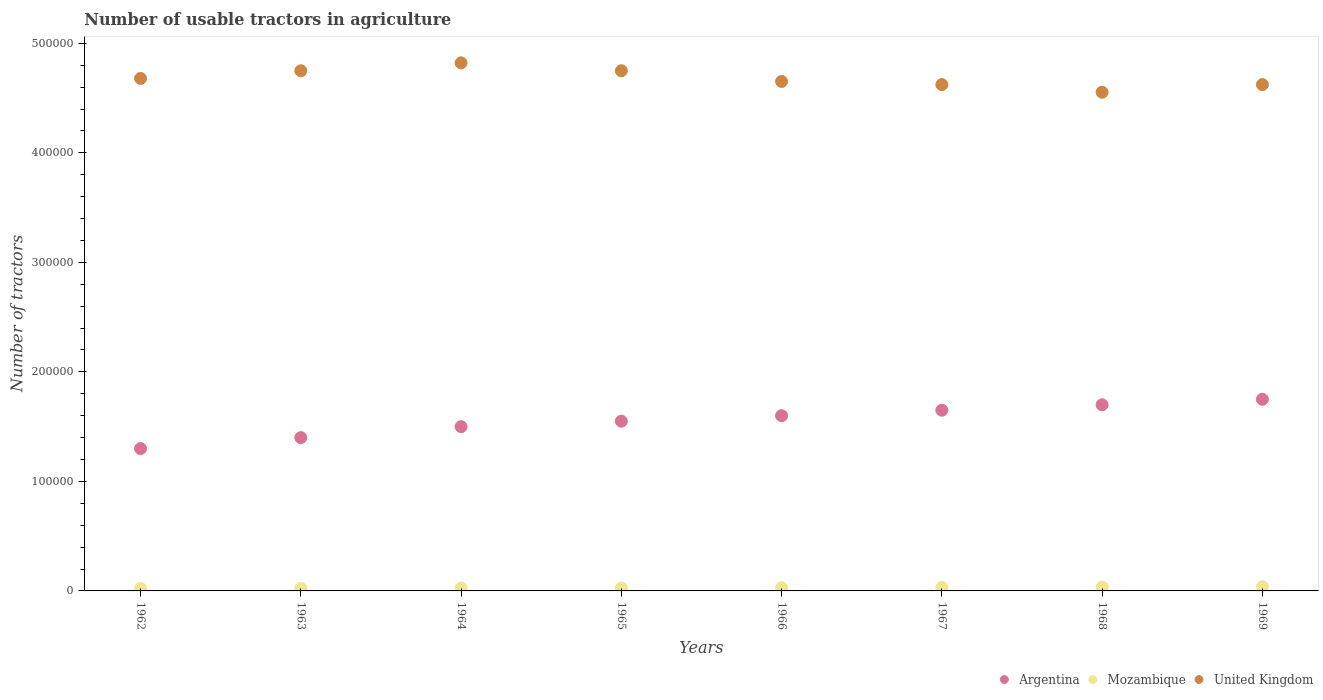What is the number of usable tractors in agriculture in Mozambique in 1966?
Give a very brief answer. 2948. Across all years, what is the maximum number of usable tractors in agriculture in Mozambique?
Provide a short and direct response. 3900. Across all years, what is the minimum number of usable tractors in agriculture in Mozambique?
Your answer should be compact. 2300. In which year was the number of usable tractors in agriculture in Mozambique maximum?
Give a very brief answer. 1969. In which year was the number of usable tractors in agriculture in United Kingdom minimum?
Make the answer very short. 1968. What is the total number of usable tractors in agriculture in Mozambique in the graph?
Your answer should be very brief. 2.38e+04. What is the difference between the number of usable tractors in agriculture in Mozambique in 1963 and that in 1964?
Make the answer very short. -150. What is the difference between the number of usable tractors in agriculture in Argentina in 1966 and the number of usable tractors in agriculture in United Kingdom in 1964?
Provide a succinct answer. -3.22e+05. What is the average number of usable tractors in agriculture in Mozambique per year?
Give a very brief answer. 2981. In the year 1969, what is the difference between the number of usable tractors in agriculture in Argentina and number of usable tractors in agriculture in United Kingdom?
Ensure brevity in your answer.  -2.87e+05. In how many years, is the number of usable tractors in agriculture in United Kingdom greater than 280000?
Make the answer very short. 8. What is the ratio of the number of usable tractors in agriculture in Argentina in 1966 to that in 1967?
Keep it short and to the point. 0.97. Is the number of usable tractors in agriculture in United Kingdom in 1965 less than that in 1968?
Give a very brief answer. No. Is the difference between the number of usable tractors in agriculture in Argentina in 1967 and 1969 greater than the difference between the number of usable tractors in agriculture in United Kingdom in 1967 and 1969?
Ensure brevity in your answer.  No. What is the difference between the highest and the second highest number of usable tractors in agriculture in United Kingdom?
Keep it short and to the point. 7210. What is the difference between the highest and the lowest number of usable tractors in agriculture in United Kingdom?
Provide a succinct answer. 2.68e+04. Is it the case that in every year, the sum of the number of usable tractors in agriculture in Argentina and number of usable tractors in agriculture in Mozambique  is greater than the number of usable tractors in agriculture in United Kingdom?
Your answer should be compact. No. Does the number of usable tractors in agriculture in Mozambique monotonically increase over the years?
Your answer should be very brief. Yes. How many dotlines are there?
Provide a succinct answer. 3. Does the graph contain any zero values?
Provide a short and direct response. No. Does the graph contain grids?
Provide a short and direct response. No. Where does the legend appear in the graph?
Provide a short and direct response. Bottom right. What is the title of the graph?
Give a very brief answer. Number of usable tractors in agriculture. What is the label or title of the X-axis?
Ensure brevity in your answer.  Years. What is the label or title of the Y-axis?
Make the answer very short. Number of tractors. What is the Number of tractors in Argentina in 1962?
Keep it short and to the point. 1.30e+05. What is the Number of tractors in Mozambique in 1962?
Keep it short and to the point. 2300. What is the Number of tractors in United Kingdom in 1962?
Your answer should be compact. 4.68e+05. What is the Number of tractors of Argentina in 1963?
Offer a terse response. 1.40e+05. What is the Number of tractors in Mozambique in 1963?
Your answer should be very brief. 2450. What is the Number of tractors in United Kingdom in 1963?
Give a very brief answer. 4.75e+05. What is the Number of tractors in Mozambique in 1964?
Offer a terse response. 2600. What is the Number of tractors in United Kingdom in 1964?
Keep it short and to the point. 4.82e+05. What is the Number of tractors of Argentina in 1965?
Make the answer very short. 1.55e+05. What is the Number of tractors in Mozambique in 1965?
Your answer should be compact. 2750. What is the Number of tractors of United Kingdom in 1965?
Keep it short and to the point. 4.75e+05. What is the Number of tractors of Mozambique in 1966?
Offer a very short reply. 2948. What is the Number of tractors of United Kingdom in 1966?
Provide a short and direct response. 4.65e+05. What is the Number of tractors in Argentina in 1967?
Keep it short and to the point. 1.65e+05. What is the Number of tractors in Mozambique in 1967?
Your answer should be compact. 3300. What is the Number of tractors of United Kingdom in 1967?
Your response must be concise. 4.62e+05. What is the Number of tractors of Mozambique in 1968?
Ensure brevity in your answer.  3600. What is the Number of tractors of United Kingdom in 1968?
Provide a succinct answer. 4.55e+05. What is the Number of tractors in Argentina in 1969?
Offer a terse response. 1.75e+05. What is the Number of tractors of Mozambique in 1969?
Ensure brevity in your answer.  3900. What is the Number of tractors of United Kingdom in 1969?
Your answer should be very brief. 4.62e+05. Across all years, what is the maximum Number of tractors in Argentina?
Provide a short and direct response. 1.75e+05. Across all years, what is the maximum Number of tractors of Mozambique?
Offer a terse response. 3900. Across all years, what is the maximum Number of tractors in United Kingdom?
Your response must be concise. 4.82e+05. Across all years, what is the minimum Number of tractors of Argentina?
Provide a short and direct response. 1.30e+05. Across all years, what is the minimum Number of tractors in Mozambique?
Your response must be concise. 2300. Across all years, what is the minimum Number of tractors in United Kingdom?
Ensure brevity in your answer.  4.55e+05. What is the total Number of tractors of Argentina in the graph?
Offer a terse response. 1.24e+06. What is the total Number of tractors of Mozambique in the graph?
Give a very brief answer. 2.38e+04. What is the total Number of tractors in United Kingdom in the graph?
Ensure brevity in your answer.  3.75e+06. What is the difference between the Number of tractors in Mozambique in 1962 and that in 1963?
Your answer should be compact. -150. What is the difference between the Number of tractors in United Kingdom in 1962 and that in 1963?
Ensure brevity in your answer.  -7000. What is the difference between the Number of tractors of Mozambique in 1962 and that in 1964?
Provide a short and direct response. -300. What is the difference between the Number of tractors of United Kingdom in 1962 and that in 1964?
Provide a short and direct response. -1.42e+04. What is the difference between the Number of tractors in Argentina in 1962 and that in 1965?
Provide a short and direct response. -2.50e+04. What is the difference between the Number of tractors of Mozambique in 1962 and that in 1965?
Your answer should be compact. -450. What is the difference between the Number of tractors in United Kingdom in 1962 and that in 1965?
Ensure brevity in your answer.  -7000. What is the difference between the Number of tractors in Mozambique in 1962 and that in 1966?
Your response must be concise. -648. What is the difference between the Number of tractors in United Kingdom in 1962 and that in 1966?
Your answer should be compact. 2780. What is the difference between the Number of tractors in Argentina in 1962 and that in 1967?
Give a very brief answer. -3.50e+04. What is the difference between the Number of tractors in Mozambique in 1962 and that in 1967?
Make the answer very short. -1000. What is the difference between the Number of tractors in United Kingdom in 1962 and that in 1967?
Give a very brief answer. 5637. What is the difference between the Number of tractors in Argentina in 1962 and that in 1968?
Ensure brevity in your answer.  -4.00e+04. What is the difference between the Number of tractors in Mozambique in 1962 and that in 1968?
Ensure brevity in your answer.  -1300. What is the difference between the Number of tractors of United Kingdom in 1962 and that in 1968?
Make the answer very short. 1.26e+04. What is the difference between the Number of tractors of Argentina in 1962 and that in 1969?
Provide a short and direct response. -4.50e+04. What is the difference between the Number of tractors in Mozambique in 1962 and that in 1969?
Your answer should be compact. -1600. What is the difference between the Number of tractors of United Kingdom in 1962 and that in 1969?
Make the answer very short. 5624. What is the difference between the Number of tractors of Mozambique in 1963 and that in 1964?
Your response must be concise. -150. What is the difference between the Number of tractors of United Kingdom in 1963 and that in 1964?
Make the answer very short. -7210. What is the difference between the Number of tractors in Argentina in 1963 and that in 1965?
Provide a succinct answer. -1.50e+04. What is the difference between the Number of tractors of Mozambique in 1963 and that in 1965?
Give a very brief answer. -300. What is the difference between the Number of tractors in Mozambique in 1963 and that in 1966?
Give a very brief answer. -498. What is the difference between the Number of tractors in United Kingdom in 1963 and that in 1966?
Provide a succinct answer. 9780. What is the difference between the Number of tractors in Argentina in 1963 and that in 1967?
Your response must be concise. -2.50e+04. What is the difference between the Number of tractors of Mozambique in 1963 and that in 1967?
Your answer should be compact. -850. What is the difference between the Number of tractors of United Kingdom in 1963 and that in 1967?
Your answer should be very brief. 1.26e+04. What is the difference between the Number of tractors in Mozambique in 1963 and that in 1968?
Keep it short and to the point. -1150. What is the difference between the Number of tractors of United Kingdom in 1963 and that in 1968?
Keep it short and to the point. 1.96e+04. What is the difference between the Number of tractors in Argentina in 1963 and that in 1969?
Offer a very short reply. -3.50e+04. What is the difference between the Number of tractors in Mozambique in 1963 and that in 1969?
Your response must be concise. -1450. What is the difference between the Number of tractors in United Kingdom in 1963 and that in 1969?
Your answer should be very brief. 1.26e+04. What is the difference between the Number of tractors of Argentina in 1964 and that in 1965?
Your response must be concise. -5000. What is the difference between the Number of tractors of Mozambique in 1964 and that in 1965?
Make the answer very short. -150. What is the difference between the Number of tractors of United Kingdom in 1964 and that in 1965?
Provide a succinct answer. 7210. What is the difference between the Number of tractors in Mozambique in 1964 and that in 1966?
Provide a succinct answer. -348. What is the difference between the Number of tractors in United Kingdom in 1964 and that in 1966?
Provide a short and direct response. 1.70e+04. What is the difference between the Number of tractors in Argentina in 1964 and that in 1967?
Offer a very short reply. -1.50e+04. What is the difference between the Number of tractors in Mozambique in 1964 and that in 1967?
Give a very brief answer. -700. What is the difference between the Number of tractors of United Kingdom in 1964 and that in 1967?
Provide a short and direct response. 1.98e+04. What is the difference between the Number of tractors in Mozambique in 1964 and that in 1968?
Offer a very short reply. -1000. What is the difference between the Number of tractors of United Kingdom in 1964 and that in 1968?
Your answer should be very brief. 2.68e+04. What is the difference between the Number of tractors in Argentina in 1964 and that in 1969?
Your answer should be compact. -2.50e+04. What is the difference between the Number of tractors in Mozambique in 1964 and that in 1969?
Offer a very short reply. -1300. What is the difference between the Number of tractors in United Kingdom in 1964 and that in 1969?
Your answer should be very brief. 1.98e+04. What is the difference between the Number of tractors of Argentina in 1965 and that in 1966?
Provide a short and direct response. -5000. What is the difference between the Number of tractors in Mozambique in 1965 and that in 1966?
Make the answer very short. -198. What is the difference between the Number of tractors of United Kingdom in 1965 and that in 1966?
Offer a terse response. 9780. What is the difference between the Number of tractors in Mozambique in 1965 and that in 1967?
Your answer should be compact. -550. What is the difference between the Number of tractors of United Kingdom in 1965 and that in 1967?
Provide a short and direct response. 1.26e+04. What is the difference between the Number of tractors of Argentina in 1965 and that in 1968?
Provide a short and direct response. -1.50e+04. What is the difference between the Number of tractors of Mozambique in 1965 and that in 1968?
Give a very brief answer. -850. What is the difference between the Number of tractors in United Kingdom in 1965 and that in 1968?
Your response must be concise. 1.96e+04. What is the difference between the Number of tractors of Argentina in 1965 and that in 1969?
Offer a very short reply. -2.00e+04. What is the difference between the Number of tractors of Mozambique in 1965 and that in 1969?
Keep it short and to the point. -1150. What is the difference between the Number of tractors in United Kingdom in 1965 and that in 1969?
Give a very brief answer. 1.26e+04. What is the difference between the Number of tractors in Argentina in 1966 and that in 1967?
Provide a short and direct response. -5000. What is the difference between the Number of tractors of Mozambique in 1966 and that in 1967?
Your response must be concise. -352. What is the difference between the Number of tractors in United Kingdom in 1966 and that in 1967?
Keep it short and to the point. 2857. What is the difference between the Number of tractors in Argentina in 1966 and that in 1968?
Your answer should be compact. -10000. What is the difference between the Number of tractors in Mozambique in 1966 and that in 1968?
Keep it short and to the point. -652. What is the difference between the Number of tractors in United Kingdom in 1966 and that in 1968?
Give a very brief answer. 9845. What is the difference between the Number of tractors of Argentina in 1966 and that in 1969?
Provide a short and direct response. -1.50e+04. What is the difference between the Number of tractors in Mozambique in 1966 and that in 1969?
Give a very brief answer. -952. What is the difference between the Number of tractors in United Kingdom in 1966 and that in 1969?
Your answer should be compact. 2844. What is the difference between the Number of tractors in Argentina in 1967 and that in 1968?
Keep it short and to the point. -5000. What is the difference between the Number of tractors of Mozambique in 1967 and that in 1968?
Your answer should be very brief. -300. What is the difference between the Number of tractors of United Kingdom in 1967 and that in 1968?
Provide a short and direct response. 6988. What is the difference between the Number of tractors in Mozambique in 1967 and that in 1969?
Keep it short and to the point. -600. What is the difference between the Number of tractors in United Kingdom in 1967 and that in 1969?
Provide a short and direct response. -13. What is the difference between the Number of tractors in Argentina in 1968 and that in 1969?
Your response must be concise. -5000. What is the difference between the Number of tractors of Mozambique in 1968 and that in 1969?
Your response must be concise. -300. What is the difference between the Number of tractors of United Kingdom in 1968 and that in 1969?
Give a very brief answer. -7001. What is the difference between the Number of tractors in Argentina in 1962 and the Number of tractors in Mozambique in 1963?
Your response must be concise. 1.28e+05. What is the difference between the Number of tractors of Argentina in 1962 and the Number of tractors of United Kingdom in 1963?
Ensure brevity in your answer.  -3.45e+05. What is the difference between the Number of tractors in Mozambique in 1962 and the Number of tractors in United Kingdom in 1963?
Keep it short and to the point. -4.73e+05. What is the difference between the Number of tractors in Argentina in 1962 and the Number of tractors in Mozambique in 1964?
Your answer should be very brief. 1.27e+05. What is the difference between the Number of tractors of Argentina in 1962 and the Number of tractors of United Kingdom in 1964?
Offer a very short reply. -3.52e+05. What is the difference between the Number of tractors in Mozambique in 1962 and the Number of tractors in United Kingdom in 1964?
Your response must be concise. -4.80e+05. What is the difference between the Number of tractors in Argentina in 1962 and the Number of tractors in Mozambique in 1965?
Give a very brief answer. 1.27e+05. What is the difference between the Number of tractors of Argentina in 1962 and the Number of tractors of United Kingdom in 1965?
Give a very brief answer. -3.45e+05. What is the difference between the Number of tractors in Mozambique in 1962 and the Number of tractors in United Kingdom in 1965?
Provide a short and direct response. -4.73e+05. What is the difference between the Number of tractors in Argentina in 1962 and the Number of tractors in Mozambique in 1966?
Offer a terse response. 1.27e+05. What is the difference between the Number of tractors of Argentina in 1962 and the Number of tractors of United Kingdom in 1966?
Your response must be concise. -3.35e+05. What is the difference between the Number of tractors of Mozambique in 1962 and the Number of tractors of United Kingdom in 1966?
Offer a terse response. -4.63e+05. What is the difference between the Number of tractors of Argentina in 1962 and the Number of tractors of Mozambique in 1967?
Make the answer very short. 1.27e+05. What is the difference between the Number of tractors in Argentina in 1962 and the Number of tractors in United Kingdom in 1967?
Offer a terse response. -3.32e+05. What is the difference between the Number of tractors of Mozambique in 1962 and the Number of tractors of United Kingdom in 1967?
Keep it short and to the point. -4.60e+05. What is the difference between the Number of tractors in Argentina in 1962 and the Number of tractors in Mozambique in 1968?
Offer a terse response. 1.26e+05. What is the difference between the Number of tractors in Argentina in 1962 and the Number of tractors in United Kingdom in 1968?
Your answer should be compact. -3.25e+05. What is the difference between the Number of tractors in Mozambique in 1962 and the Number of tractors in United Kingdom in 1968?
Provide a short and direct response. -4.53e+05. What is the difference between the Number of tractors of Argentina in 1962 and the Number of tractors of Mozambique in 1969?
Your answer should be very brief. 1.26e+05. What is the difference between the Number of tractors of Argentina in 1962 and the Number of tractors of United Kingdom in 1969?
Provide a succinct answer. -3.32e+05. What is the difference between the Number of tractors of Mozambique in 1962 and the Number of tractors of United Kingdom in 1969?
Your response must be concise. -4.60e+05. What is the difference between the Number of tractors of Argentina in 1963 and the Number of tractors of Mozambique in 1964?
Ensure brevity in your answer.  1.37e+05. What is the difference between the Number of tractors in Argentina in 1963 and the Number of tractors in United Kingdom in 1964?
Offer a very short reply. -3.42e+05. What is the difference between the Number of tractors in Mozambique in 1963 and the Number of tractors in United Kingdom in 1964?
Your answer should be compact. -4.80e+05. What is the difference between the Number of tractors of Argentina in 1963 and the Number of tractors of Mozambique in 1965?
Your answer should be compact. 1.37e+05. What is the difference between the Number of tractors of Argentina in 1963 and the Number of tractors of United Kingdom in 1965?
Your answer should be very brief. -3.35e+05. What is the difference between the Number of tractors of Mozambique in 1963 and the Number of tractors of United Kingdom in 1965?
Provide a succinct answer. -4.73e+05. What is the difference between the Number of tractors in Argentina in 1963 and the Number of tractors in Mozambique in 1966?
Keep it short and to the point. 1.37e+05. What is the difference between the Number of tractors of Argentina in 1963 and the Number of tractors of United Kingdom in 1966?
Your answer should be very brief. -3.25e+05. What is the difference between the Number of tractors in Mozambique in 1963 and the Number of tractors in United Kingdom in 1966?
Make the answer very short. -4.63e+05. What is the difference between the Number of tractors of Argentina in 1963 and the Number of tractors of Mozambique in 1967?
Offer a terse response. 1.37e+05. What is the difference between the Number of tractors of Argentina in 1963 and the Number of tractors of United Kingdom in 1967?
Provide a short and direct response. -3.22e+05. What is the difference between the Number of tractors in Mozambique in 1963 and the Number of tractors in United Kingdom in 1967?
Give a very brief answer. -4.60e+05. What is the difference between the Number of tractors of Argentina in 1963 and the Number of tractors of Mozambique in 1968?
Your answer should be very brief. 1.36e+05. What is the difference between the Number of tractors of Argentina in 1963 and the Number of tractors of United Kingdom in 1968?
Your answer should be compact. -3.15e+05. What is the difference between the Number of tractors in Mozambique in 1963 and the Number of tractors in United Kingdom in 1968?
Provide a succinct answer. -4.53e+05. What is the difference between the Number of tractors of Argentina in 1963 and the Number of tractors of Mozambique in 1969?
Ensure brevity in your answer.  1.36e+05. What is the difference between the Number of tractors in Argentina in 1963 and the Number of tractors in United Kingdom in 1969?
Make the answer very short. -3.22e+05. What is the difference between the Number of tractors in Mozambique in 1963 and the Number of tractors in United Kingdom in 1969?
Your response must be concise. -4.60e+05. What is the difference between the Number of tractors of Argentina in 1964 and the Number of tractors of Mozambique in 1965?
Offer a terse response. 1.47e+05. What is the difference between the Number of tractors of Argentina in 1964 and the Number of tractors of United Kingdom in 1965?
Provide a succinct answer. -3.25e+05. What is the difference between the Number of tractors in Mozambique in 1964 and the Number of tractors in United Kingdom in 1965?
Provide a short and direct response. -4.72e+05. What is the difference between the Number of tractors in Argentina in 1964 and the Number of tractors in Mozambique in 1966?
Offer a very short reply. 1.47e+05. What is the difference between the Number of tractors of Argentina in 1964 and the Number of tractors of United Kingdom in 1966?
Keep it short and to the point. -3.15e+05. What is the difference between the Number of tractors of Mozambique in 1964 and the Number of tractors of United Kingdom in 1966?
Make the answer very short. -4.63e+05. What is the difference between the Number of tractors of Argentina in 1964 and the Number of tractors of Mozambique in 1967?
Keep it short and to the point. 1.47e+05. What is the difference between the Number of tractors of Argentina in 1964 and the Number of tractors of United Kingdom in 1967?
Offer a terse response. -3.12e+05. What is the difference between the Number of tractors in Mozambique in 1964 and the Number of tractors in United Kingdom in 1967?
Give a very brief answer. -4.60e+05. What is the difference between the Number of tractors in Argentina in 1964 and the Number of tractors in Mozambique in 1968?
Your answer should be compact. 1.46e+05. What is the difference between the Number of tractors in Argentina in 1964 and the Number of tractors in United Kingdom in 1968?
Make the answer very short. -3.05e+05. What is the difference between the Number of tractors of Mozambique in 1964 and the Number of tractors of United Kingdom in 1968?
Your response must be concise. -4.53e+05. What is the difference between the Number of tractors in Argentina in 1964 and the Number of tractors in Mozambique in 1969?
Ensure brevity in your answer.  1.46e+05. What is the difference between the Number of tractors of Argentina in 1964 and the Number of tractors of United Kingdom in 1969?
Provide a short and direct response. -3.12e+05. What is the difference between the Number of tractors in Mozambique in 1964 and the Number of tractors in United Kingdom in 1969?
Offer a terse response. -4.60e+05. What is the difference between the Number of tractors in Argentina in 1965 and the Number of tractors in Mozambique in 1966?
Your answer should be very brief. 1.52e+05. What is the difference between the Number of tractors of Argentina in 1965 and the Number of tractors of United Kingdom in 1966?
Provide a succinct answer. -3.10e+05. What is the difference between the Number of tractors of Mozambique in 1965 and the Number of tractors of United Kingdom in 1966?
Make the answer very short. -4.62e+05. What is the difference between the Number of tractors of Argentina in 1965 and the Number of tractors of Mozambique in 1967?
Provide a short and direct response. 1.52e+05. What is the difference between the Number of tractors in Argentina in 1965 and the Number of tractors in United Kingdom in 1967?
Your answer should be very brief. -3.07e+05. What is the difference between the Number of tractors of Mozambique in 1965 and the Number of tractors of United Kingdom in 1967?
Your answer should be compact. -4.60e+05. What is the difference between the Number of tractors in Argentina in 1965 and the Number of tractors in Mozambique in 1968?
Provide a short and direct response. 1.51e+05. What is the difference between the Number of tractors in Argentina in 1965 and the Number of tractors in United Kingdom in 1968?
Make the answer very short. -3.00e+05. What is the difference between the Number of tractors of Mozambique in 1965 and the Number of tractors of United Kingdom in 1968?
Your answer should be very brief. -4.53e+05. What is the difference between the Number of tractors in Argentina in 1965 and the Number of tractors in Mozambique in 1969?
Your response must be concise. 1.51e+05. What is the difference between the Number of tractors of Argentina in 1965 and the Number of tractors of United Kingdom in 1969?
Your answer should be very brief. -3.07e+05. What is the difference between the Number of tractors of Mozambique in 1965 and the Number of tractors of United Kingdom in 1969?
Give a very brief answer. -4.60e+05. What is the difference between the Number of tractors in Argentina in 1966 and the Number of tractors in Mozambique in 1967?
Keep it short and to the point. 1.57e+05. What is the difference between the Number of tractors of Argentina in 1966 and the Number of tractors of United Kingdom in 1967?
Keep it short and to the point. -3.02e+05. What is the difference between the Number of tractors in Mozambique in 1966 and the Number of tractors in United Kingdom in 1967?
Your answer should be very brief. -4.59e+05. What is the difference between the Number of tractors in Argentina in 1966 and the Number of tractors in Mozambique in 1968?
Keep it short and to the point. 1.56e+05. What is the difference between the Number of tractors of Argentina in 1966 and the Number of tractors of United Kingdom in 1968?
Offer a terse response. -2.95e+05. What is the difference between the Number of tractors of Mozambique in 1966 and the Number of tractors of United Kingdom in 1968?
Your response must be concise. -4.52e+05. What is the difference between the Number of tractors of Argentina in 1966 and the Number of tractors of Mozambique in 1969?
Ensure brevity in your answer.  1.56e+05. What is the difference between the Number of tractors in Argentina in 1966 and the Number of tractors in United Kingdom in 1969?
Ensure brevity in your answer.  -3.02e+05. What is the difference between the Number of tractors of Mozambique in 1966 and the Number of tractors of United Kingdom in 1969?
Your answer should be compact. -4.59e+05. What is the difference between the Number of tractors in Argentina in 1967 and the Number of tractors in Mozambique in 1968?
Give a very brief answer. 1.61e+05. What is the difference between the Number of tractors of Argentina in 1967 and the Number of tractors of United Kingdom in 1968?
Offer a terse response. -2.90e+05. What is the difference between the Number of tractors of Mozambique in 1967 and the Number of tractors of United Kingdom in 1968?
Make the answer very short. -4.52e+05. What is the difference between the Number of tractors in Argentina in 1967 and the Number of tractors in Mozambique in 1969?
Your response must be concise. 1.61e+05. What is the difference between the Number of tractors in Argentina in 1967 and the Number of tractors in United Kingdom in 1969?
Your answer should be compact. -2.97e+05. What is the difference between the Number of tractors of Mozambique in 1967 and the Number of tractors of United Kingdom in 1969?
Your response must be concise. -4.59e+05. What is the difference between the Number of tractors of Argentina in 1968 and the Number of tractors of Mozambique in 1969?
Give a very brief answer. 1.66e+05. What is the difference between the Number of tractors in Argentina in 1968 and the Number of tractors in United Kingdom in 1969?
Your response must be concise. -2.92e+05. What is the difference between the Number of tractors in Mozambique in 1968 and the Number of tractors in United Kingdom in 1969?
Ensure brevity in your answer.  -4.59e+05. What is the average Number of tractors of Argentina per year?
Your response must be concise. 1.56e+05. What is the average Number of tractors of Mozambique per year?
Your answer should be compact. 2981. What is the average Number of tractors of United Kingdom per year?
Provide a short and direct response. 4.68e+05. In the year 1962, what is the difference between the Number of tractors in Argentina and Number of tractors in Mozambique?
Offer a terse response. 1.28e+05. In the year 1962, what is the difference between the Number of tractors in Argentina and Number of tractors in United Kingdom?
Give a very brief answer. -3.38e+05. In the year 1962, what is the difference between the Number of tractors in Mozambique and Number of tractors in United Kingdom?
Offer a very short reply. -4.66e+05. In the year 1963, what is the difference between the Number of tractors in Argentina and Number of tractors in Mozambique?
Make the answer very short. 1.38e+05. In the year 1963, what is the difference between the Number of tractors in Argentina and Number of tractors in United Kingdom?
Offer a terse response. -3.35e+05. In the year 1963, what is the difference between the Number of tractors in Mozambique and Number of tractors in United Kingdom?
Make the answer very short. -4.73e+05. In the year 1964, what is the difference between the Number of tractors of Argentina and Number of tractors of Mozambique?
Offer a terse response. 1.47e+05. In the year 1964, what is the difference between the Number of tractors in Argentina and Number of tractors in United Kingdom?
Offer a terse response. -3.32e+05. In the year 1964, what is the difference between the Number of tractors in Mozambique and Number of tractors in United Kingdom?
Make the answer very short. -4.80e+05. In the year 1965, what is the difference between the Number of tractors in Argentina and Number of tractors in Mozambique?
Keep it short and to the point. 1.52e+05. In the year 1965, what is the difference between the Number of tractors of Argentina and Number of tractors of United Kingdom?
Offer a terse response. -3.20e+05. In the year 1965, what is the difference between the Number of tractors in Mozambique and Number of tractors in United Kingdom?
Your answer should be compact. -4.72e+05. In the year 1966, what is the difference between the Number of tractors of Argentina and Number of tractors of Mozambique?
Your answer should be compact. 1.57e+05. In the year 1966, what is the difference between the Number of tractors of Argentina and Number of tractors of United Kingdom?
Ensure brevity in your answer.  -3.05e+05. In the year 1966, what is the difference between the Number of tractors in Mozambique and Number of tractors in United Kingdom?
Keep it short and to the point. -4.62e+05. In the year 1967, what is the difference between the Number of tractors of Argentina and Number of tractors of Mozambique?
Make the answer very short. 1.62e+05. In the year 1967, what is the difference between the Number of tractors of Argentina and Number of tractors of United Kingdom?
Your response must be concise. -2.97e+05. In the year 1967, what is the difference between the Number of tractors in Mozambique and Number of tractors in United Kingdom?
Offer a very short reply. -4.59e+05. In the year 1968, what is the difference between the Number of tractors in Argentina and Number of tractors in Mozambique?
Your answer should be compact. 1.66e+05. In the year 1968, what is the difference between the Number of tractors in Argentina and Number of tractors in United Kingdom?
Make the answer very short. -2.85e+05. In the year 1968, what is the difference between the Number of tractors in Mozambique and Number of tractors in United Kingdom?
Offer a very short reply. -4.52e+05. In the year 1969, what is the difference between the Number of tractors of Argentina and Number of tractors of Mozambique?
Provide a succinct answer. 1.71e+05. In the year 1969, what is the difference between the Number of tractors in Argentina and Number of tractors in United Kingdom?
Give a very brief answer. -2.87e+05. In the year 1969, what is the difference between the Number of tractors of Mozambique and Number of tractors of United Kingdom?
Your answer should be very brief. -4.58e+05. What is the ratio of the Number of tractors in Mozambique in 1962 to that in 1963?
Offer a very short reply. 0.94. What is the ratio of the Number of tractors in Argentina in 1962 to that in 1964?
Give a very brief answer. 0.87. What is the ratio of the Number of tractors of Mozambique in 1962 to that in 1964?
Offer a terse response. 0.88. What is the ratio of the Number of tractors in United Kingdom in 1962 to that in 1964?
Provide a succinct answer. 0.97. What is the ratio of the Number of tractors in Argentina in 1962 to that in 1965?
Keep it short and to the point. 0.84. What is the ratio of the Number of tractors in Mozambique in 1962 to that in 1965?
Your answer should be very brief. 0.84. What is the ratio of the Number of tractors of Argentina in 1962 to that in 1966?
Keep it short and to the point. 0.81. What is the ratio of the Number of tractors in Mozambique in 1962 to that in 1966?
Your response must be concise. 0.78. What is the ratio of the Number of tractors of Argentina in 1962 to that in 1967?
Offer a very short reply. 0.79. What is the ratio of the Number of tractors of Mozambique in 1962 to that in 1967?
Your answer should be very brief. 0.7. What is the ratio of the Number of tractors of United Kingdom in 1962 to that in 1967?
Ensure brevity in your answer.  1.01. What is the ratio of the Number of tractors of Argentina in 1962 to that in 1968?
Your answer should be very brief. 0.76. What is the ratio of the Number of tractors in Mozambique in 1962 to that in 1968?
Offer a very short reply. 0.64. What is the ratio of the Number of tractors of United Kingdom in 1962 to that in 1968?
Provide a succinct answer. 1.03. What is the ratio of the Number of tractors of Argentina in 1962 to that in 1969?
Provide a short and direct response. 0.74. What is the ratio of the Number of tractors in Mozambique in 1962 to that in 1969?
Provide a short and direct response. 0.59. What is the ratio of the Number of tractors in United Kingdom in 1962 to that in 1969?
Your answer should be very brief. 1.01. What is the ratio of the Number of tractors of Mozambique in 1963 to that in 1964?
Your response must be concise. 0.94. What is the ratio of the Number of tractors in United Kingdom in 1963 to that in 1964?
Your answer should be compact. 0.98. What is the ratio of the Number of tractors in Argentina in 1963 to that in 1965?
Your answer should be compact. 0.9. What is the ratio of the Number of tractors of Mozambique in 1963 to that in 1965?
Your answer should be compact. 0.89. What is the ratio of the Number of tractors of United Kingdom in 1963 to that in 1965?
Make the answer very short. 1. What is the ratio of the Number of tractors of Argentina in 1963 to that in 1966?
Your answer should be compact. 0.88. What is the ratio of the Number of tractors of Mozambique in 1963 to that in 1966?
Give a very brief answer. 0.83. What is the ratio of the Number of tractors in United Kingdom in 1963 to that in 1966?
Keep it short and to the point. 1.02. What is the ratio of the Number of tractors of Argentina in 1963 to that in 1967?
Ensure brevity in your answer.  0.85. What is the ratio of the Number of tractors of Mozambique in 1963 to that in 1967?
Your answer should be very brief. 0.74. What is the ratio of the Number of tractors in United Kingdom in 1963 to that in 1967?
Make the answer very short. 1.03. What is the ratio of the Number of tractors of Argentina in 1963 to that in 1968?
Your response must be concise. 0.82. What is the ratio of the Number of tractors of Mozambique in 1963 to that in 1968?
Keep it short and to the point. 0.68. What is the ratio of the Number of tractors of United Kingdom in 1963 to that in 1968?
Your answer should be compact. 1.04. What is the ratio of the Number of tractors of Argentina in 1963 to that in 1969?
Give a very brief answer. 0.8. What is the ratio of the Number of tractors of Mozambique in 1963 to that in 1969?
Provide a succinct answer. 0.63. What is the ratio of the Number of tractors in United Kingdom in 1963 to that in 1969?
Your answer should be very brief. 1.03. What is the ratio of the Number of tractors of Argentina in 1964 to that in 1965?
Provide a succinct answer. 0.97. What is the ratio of the Number of tractors in Mozambique in 1964 to that in 1965?
Ensure brevity in your answer.  0.95. What is the ratio of the Number of tractors in United Kingdom in 1964 to that in 1965?
Your response must be concise. 1.02. What is the ratio of the Number of tractors in Argentina in 1964 to that in 1966?
Your response must be concise. 0.94. What is the ratio of the Number of tractors of Mozambique in 1964 to that in 1966?
Give a very brief answer. 0.88. What is the ratio of the Number of tractors of United Kingdom in 1964 to that in 1966?
Your answer should be compact. 1.04. What is the ratio of the Number of tractors in Argentina in 1964 to that in 1967?
Your answer should be very brief. 0.91. What is the ratio of the Number of tractors in Mozambique in 1964 to that in 1967?
Offer a terse response. 0.79. What is the ratio of the Number of tractors of United Kingdom in 1964 to that in 1967?
Offer a very short reply. 1.04. What is the ratio of the Number of tractors of Argentina in 1964 to that in 1968?
Your answer should be very brief. 0.88. What is the ratio of the Number of tractors in Mozambique in 1964 to that in 1968?
Your response must be concise. 0.72. What is the ratio of the Number of tractors in United Kingdom in 1964 to that in 1968?
Provide a succinct answer. 1.06. What is the ratio of the Number of tractors in Argentina in 1964 to that in 1969?
Your response must be concise. 0.86. What is the ratio of the Number of tractors of Mozambique in 1964 to that in 1969?
Provide a succinct answer. 0.67. What is the ratio of the Number of tractors in United Kingdom in 1964 to that in 1969?
Provide a short and direct response. 1.04. What is the ratio of the Number of tractors of Argentina in 1965 to that in 1966?
Offer a very short reply. 0.97. What is the ratio of the Number of tractors in Mozambique in 1965 to that in 1966?
Your answer should be very brief. 0.93. What is the ratio of the Number of tractors in Argentina in 1965 to that in 1967?
Provide a short and direct response. 0.94. What is the ratio of the Number of tractors of Mozambique in 1965 to that in 1967?
Offer a terse response. 0.83. What is the ratio of the Number of tractors of United Kingdom in 1965 to that in 1967?
Your answer should be compact. 1.03. What is the ratio of the Number of tractors in Argentina in 1965 to that in 1968?
Offer a terse response. 0.91. What is the ratio of the Number of tractors in Mozambique in 1965 to that in 1968?
Give a very brief answer. 0.76. What is the ratio of the Number of tractors of United Kingdom in 1965 to that in 1968?
Make the answer very short. 1.04. What is the ratio of the Number of tractors in Argentina in 1965 to that in 1969?
Your answer should be compact. 0.89. What is the ratio of the Number of tractors in Mozambique in 1965 to that in 1969?
Your response must be concise. 0.71. What is the ratio of the Number of tractors in United Kingdom in 1965 to that in 1969?
Offer a terse response. 1.03. What is the ratio of the Number of tractors of Argentina in 1966 to that in 1967?
Your response must be concise. 0.97. What is the ratio of the Number of tractors of Mozambique in 1966 to that in 1967?
Offer a terse response. 0.89. What is the ratio of the Number of tractors in United Kingdom in 1966 to that in 1967?
Make the answer very short. 1.01. What is the ratio of the Number of tractors in Argentina in 1966 to that in 1968?
Offer a very short reply. 0.94. What is the ratio of the Number of tractors in Mozambique in 1966 to that in 1968?
Your response must be concise. 0.82. What is the ratio of the Number of tractors of United Kingdom in 1966 to that in 1968?
Offer a very short reply. 1.02. What is the ratio of the Number of tractors in Argentina in 1966 to that in 1969?
Your answer should be compact. 0.91. What is the ratio of the Number of tractors in Mozambique in 1966 to that in 1969?
Make the answer very short. 0.76. What is the ratio of the Number of tractors of United Kingdom in 1966 to that in 1969?
Give a very brief answer. 1.01. What is the ratio of the Number of tractors of Argentina in 1967 to that in 1968?
Provide a short and direct response. 0.97. What is the ratio of the Number of tractors of United Kingdom in 1967 to that in 1968?
Provide a succinct answer. 1.02. What is the ratio of the Number of tractors in Argentina in 1967 to that in 1969?
Keep it short and to the point. 0.94. What is the ratio of the Number of tractors of Mozambique in 1967 to that in 1969?
Ensure brevity in your answer.  0.85. What is the ratio of the Number of tractors in United Kingdom in 1967 to that in 1969?
Keep it short and to the point. 1. What is the ratio of the Number of tractors in Argentina in 1968 to that in 1969?
Provide a succinct answer. 0.97. What is the ratio of the Number of tractors in United Kingdom in 1968 to that in 1969?
Offer a terse response. 0.98. What is the difference between the highest and the second highest Number of tractors in Argentina?
Offer a terse response. 5000. What is the difference between the highest and the second highest Number of tractors in Mozambique?
Keep it short and to the point. 300. What is the difference between the highest and the second highest Number of tractors of United Kingdom?
Your response must be concise. 7210. What is the difference between the highest and the lowest Number of tractors of Argentina?
Offer a terse response. 4.50e+04. What is the difference between the highest and the lowest Number of tractors in Mozambique?
Provide a short and direct response. 1600. What is the difference between the highest and the lowest Number of tractors in United Kingdom?
Provide a succinct answer. 2.68e+04. 